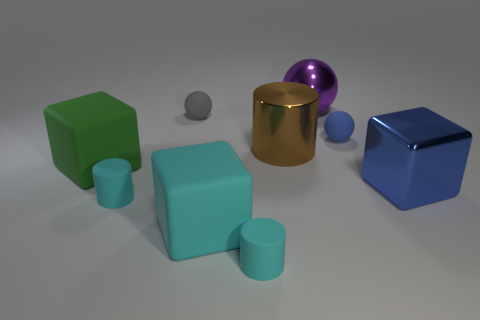Subtract all large metallic cylinders. How many cylinders are left? 2 Subtract all blue cubes. How many cubes are left? 2 Subtract all blocks. How many objects are left? 6 Subtract 3 balls. How many balls are left? 0 Add 1 blue cubes. How many objects exist? 10 Add 2 large green matte blocks. How many large green matte blocks are left? 3 Add 7 brown rubber cylinders. How many brown rubber cylinders exist? 7 Subtract 0 cyan balls. How many objects are left? 9 Subtract all blue cylinders. Subtract all blue cubes. How many cylinders are left? 3 Subtract all green cylinders. How many green balls are left? 0 